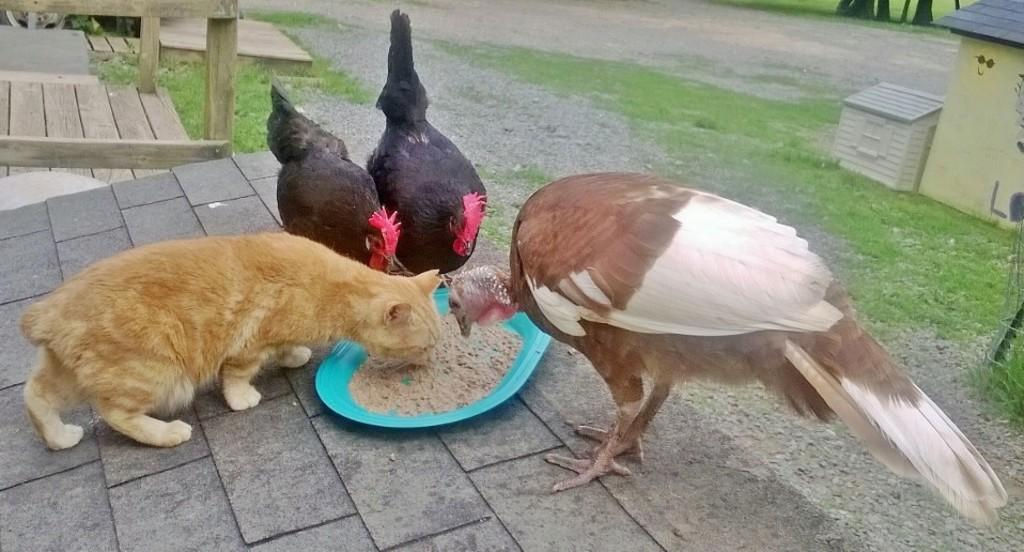What type of animal is present in the image? There is a cat, two hens, and a bird in the image. What are the animals doing in the image? The animals are eating food from a plate. What is the background of the image? There is grass visible in the image. Are there any architectural features in the image? Yes, there are wooden stairs in the image. How many jellyfish can be seen swimming in the image? There are no jellyfish present in the image. What type of spy equipment is visible in the image? There is no spy equipment present in the image. 